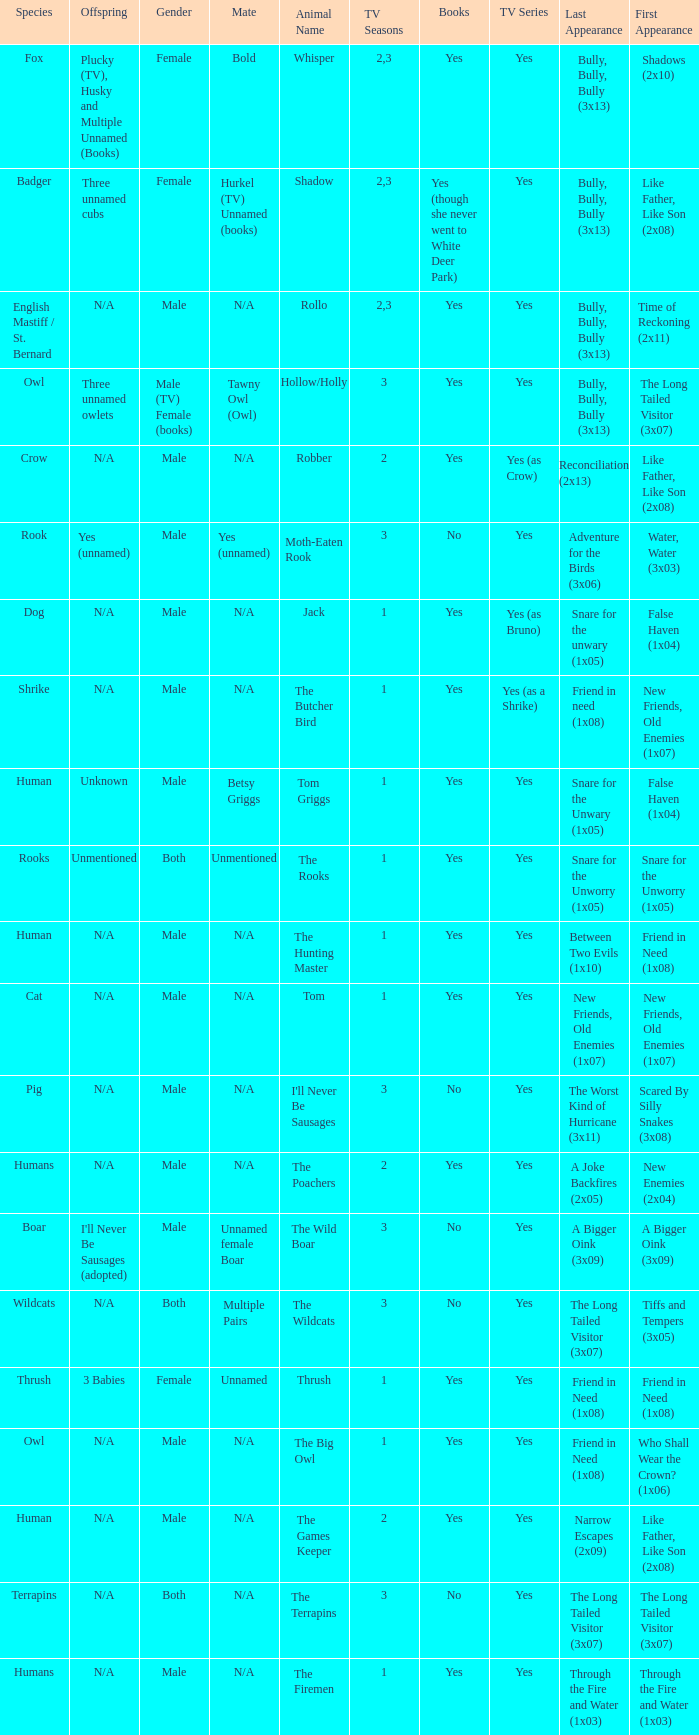What animal was yes for tv series and was a terrapins? The Terrapins. 